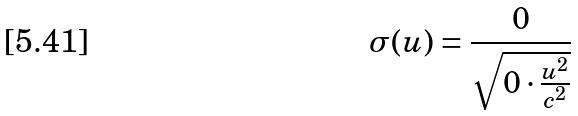<formula> <loc_0><loc_0><loc_500><loc_500>\sigma ( u ) = \frac { 0 } { \sqrt { 0 \cdot \frac { u ^ { 2 } } { c ^ { 2 } } } }</formula> 